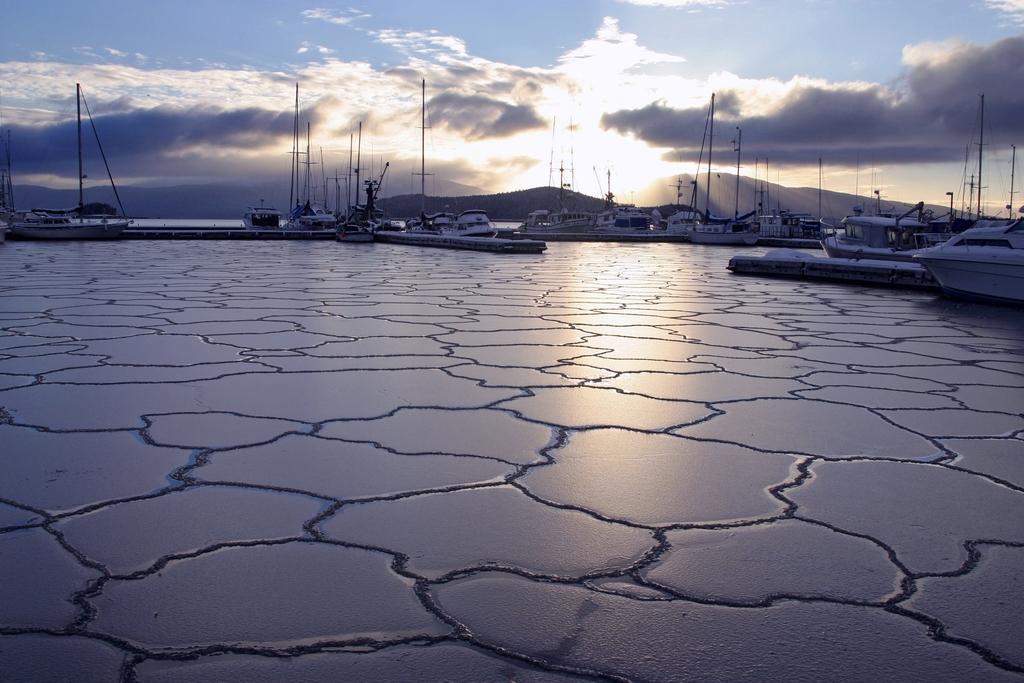Could you give a brief overview of what you see in this image? At the bottom of the image there is ice, above the ice there are some ships. Behind the ships there are some hills and clouds and sky and sun. 